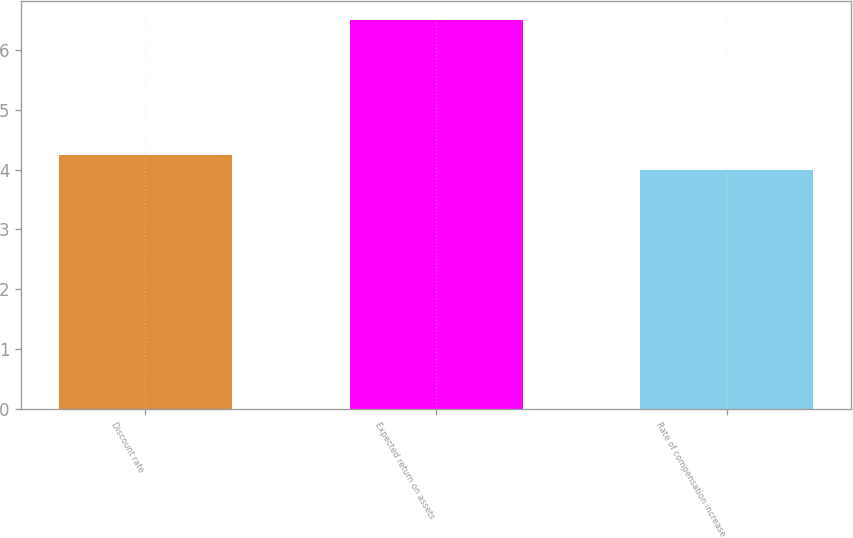Convert chart. <chart><loc_0><loc_0><loc_500><loc_500><bar_chart><fcel>Discount rate<fcel>Expected return on assets<fcel>Rate of compensation increase<nl><fcel>4.25<fcel>6.5<fcel>4<nl></chart> 